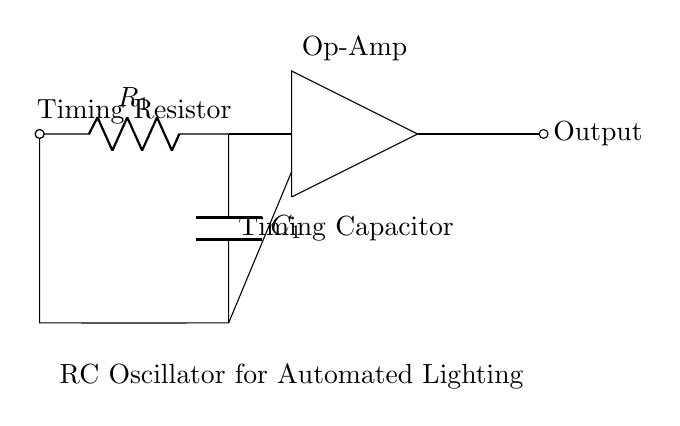What type of circuit is this? This circuit is an RC oscillator, which uses resistors and capacitors to generate oscillating signals for timing purposes. The presence of a resistor and capacitor in the feedback loop indicates it is indeed an RC oscillator.
Answer: RC oscillator What component is labeled as R1? The component labeled as R1 is the timing resistor. It is crucial for determining the time period of the oscillation based on its resistance value.
Answer: Timing resistor What is the role of C1 in this circuit? C1, the timing capacitor, stores and releases electrical energy, controlling the timing of the oscillation in conjunction with R1. It influences how quickly the circuit oscillates.
Answer: Timing capacitor How many main components are visible in the circuit? There are three main components visible in this circuit: a resistor, a capacitor, and an operational amplifier (op-amp). Each plays a distinct role in the operation of the oscillator.
Answer: Three What happens to the oscillation frequency if R1 is increased? If R1 is increased, the oscillation frequency will decrease, as the time constant of the RC network increases, resulting in longer charge and discharge times for C1.
Answer: Decrease Which component provides amplification in this circuit? The amplification is provided by the operational amplifier (op-amp), which takes the feedback from the RC network and generates a higher output signal.
Answer: Op-amp What is the purpose of this RC oscillator in automated lighting systems? The purpose of this RC oscillator is to create a timing signal that can be used to control the on/off cycles of lighting systems, ensuring they function automatically based on preset intervals.
Answer: Timing control 